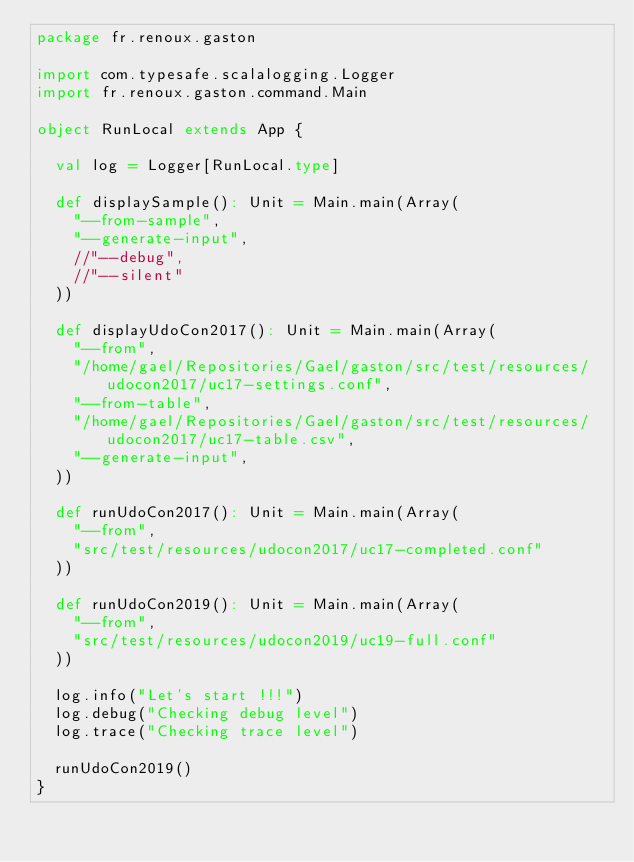Convert code to text. <code><loc_0><loc_0><loc_500><loc_500><_Scala_>package fr.renoux.gaston

import com.typesafe.scalalogging.Logger
import fr.renoux.gaston.command.Main

object RunLocal extends App {

  val log = Logger[RunLocal.type]

  def displaySample(): Unit = Main.main(Array(
    "--from-sample",
    "--generate-input",
    //"--debug",
    //"--silent"
  ))

  def displayUdoCon2017(): Unit = Main.main(Array(
    "--from",
    "/home/gael/Repositories/Gael/gaston/src/test/resources/udocon2017/uc17-settings.conf",
    "--from-table",
    "/home/gael/Repositories/Gael/gaston/src/test/resources/udocon2017/uc17-table.csv",
    "--generate-input",
  ))

  def runUdoCon2017(): Unit = Main.main(Array(
    "--from",
    "src/test/resources/udocon2017/uc17-completed.conf"
  ))

  def runUdoCon2019(): Unit = Main.main(Array(
    "--from",
    "src/test/resources/udocon2019/uc19-full.conf"
  ))

  log.info("Let's start !!!")
  log.debug("Checking debug level")
  log.trace("Checking trace level")

  runUdoCon2019()
}
</code> 